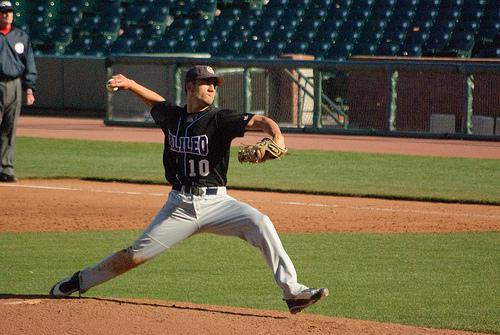Question: why is the man throwing the ball?
Choices:
A. He is playing catch.
B. He is a pitcher.
C. He is trying to hit the window.
D. He is exercising.
Answer with the letter. Answer: B Question: who is standing in the back?
Choices:
A. A coach.
B. An umpire.
C. A spectator.
D. A player.
Answer with the letter. Answer: A Question: what color is the grass?
Choices:
A. Yellow.
B. Brown.
C. Black.
D. Green.
Answer with the letter. Answer: D 